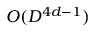<formula> <loc_0><loc_0><loc_500><loc_500>O ( D ^ { 4 d - 1 } )</formula> 